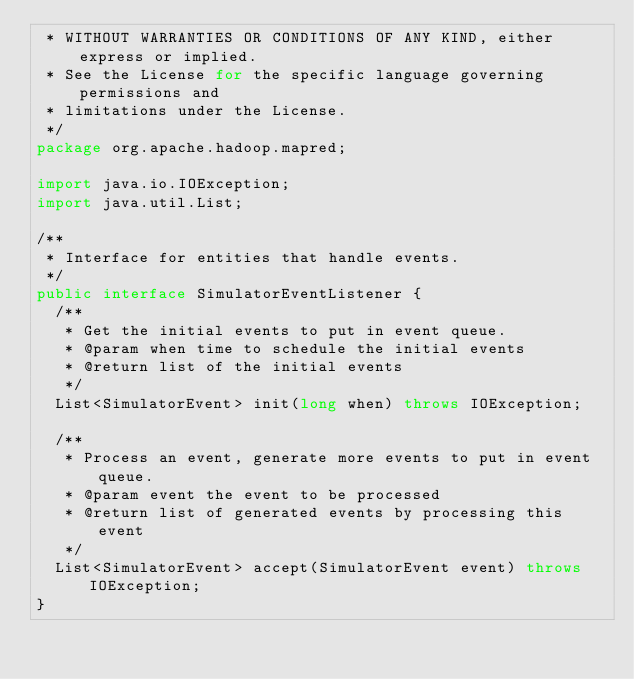<code> <loc_0><loc_0><loc_500><loc_500><_Java_> * WITHOUT WARRANTIES OR CONDITIONS OF ANY KIND, either express or implied.
 * See the License for the specific language governing permissions and
 * limitations under the License.
 */
package org.apache.hadoop.mapred;

import java.io.IOException;
import java.util.List;

/**
 * Interface for entities that handle events.
 */
public interface SimulatorEventListener {
  /**
   * Get the initial events to put in event queue.
   * @param when time to schedule the initial events
   * @return list of the initial events
   */
  List<SimulatorEvent> init(long when) throws IOException;
  
  /**
   * Process an event, generate more events to put in event queue.
   * @param event the event to be processed
   * @return list of generated events by processing this event
   */
  List<SimulatorEvent> accept(SimulatorEvent event) throws IOException;
}
</code> 